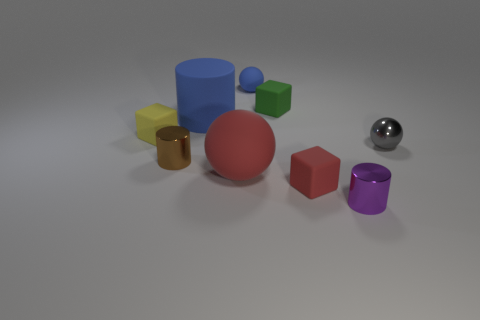Are the red sphere and the purple object made of the same material?
Provide a short and direct response. No. The shiny object right of the cylinder on the right side of the large blue cylinder that is on the left side of the small blue rubber sphere is what color?
Make the answer very short. Gray. What number of things are either rubber things that are on the right side of the yellow cube or blue matte balls?
Provide a short and direct response. 5. What material is the blue sphere that is the same size as the brown metal cylinder?
Your response must be concise. Rubber. What is the material of the small cube in front of the block on the left side of the small matte block that is behind the small yellow cube?
Give a very brief answer. Rubber. What color is the metal sphere?
Make the answer very short. Gray. What number of large objects are green shiny things or blue rubber cylinders?
Your response must be concise. 1. Is the large object on the right side of the blue cylinder made of the same material as the tiny purple object that is in front of the tiny metal ball?
Make the answer very short. No. Are any gray spheres visible?
Keep it short and to the point. Yes. Is the number of small balls that are in front of the tiny green matte thing greater than the number of large cylinders that are in front of the large red matte ball?
Provide a short and direct response. Yes. 